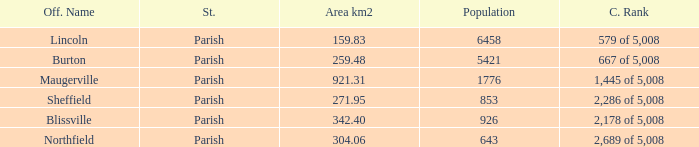What are the official name(s) of places with an area of 304.06 km2? Northfield. 